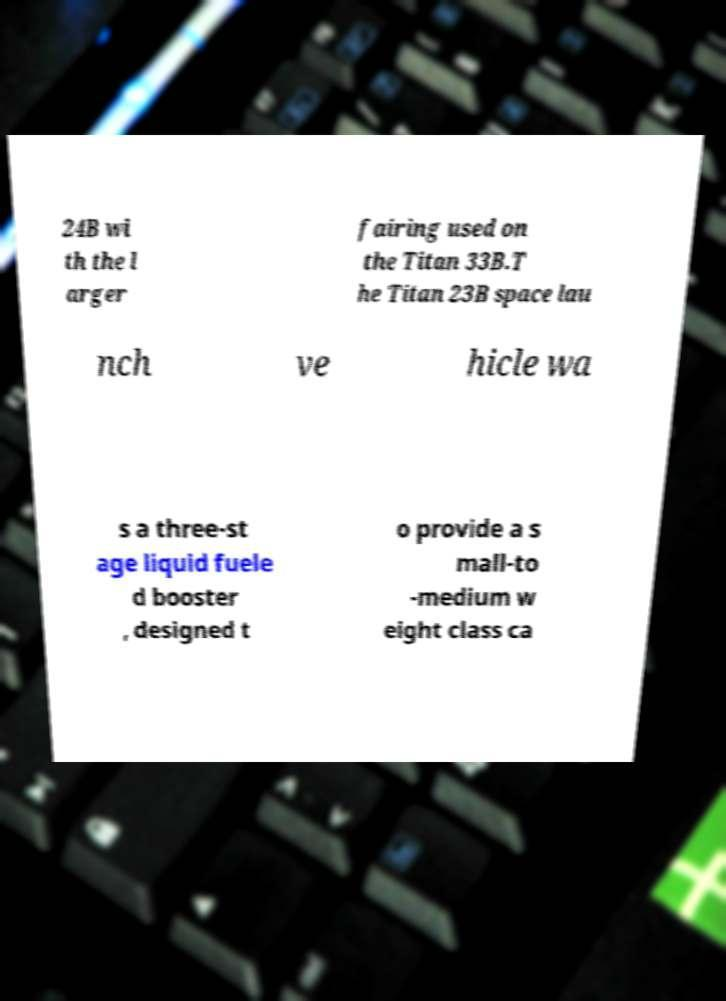Can you read and provide the text displayed in the image?This photo seems to have some interesting text. Can you extract and type it out for me? 24B wi th the l arger fairing used on the Titan 33B.T he Titan 23B space lau nch ve hicle wa s a three-st age liquid fuele d booster , designed t o provide a s mall-to -medium w eight class ca 